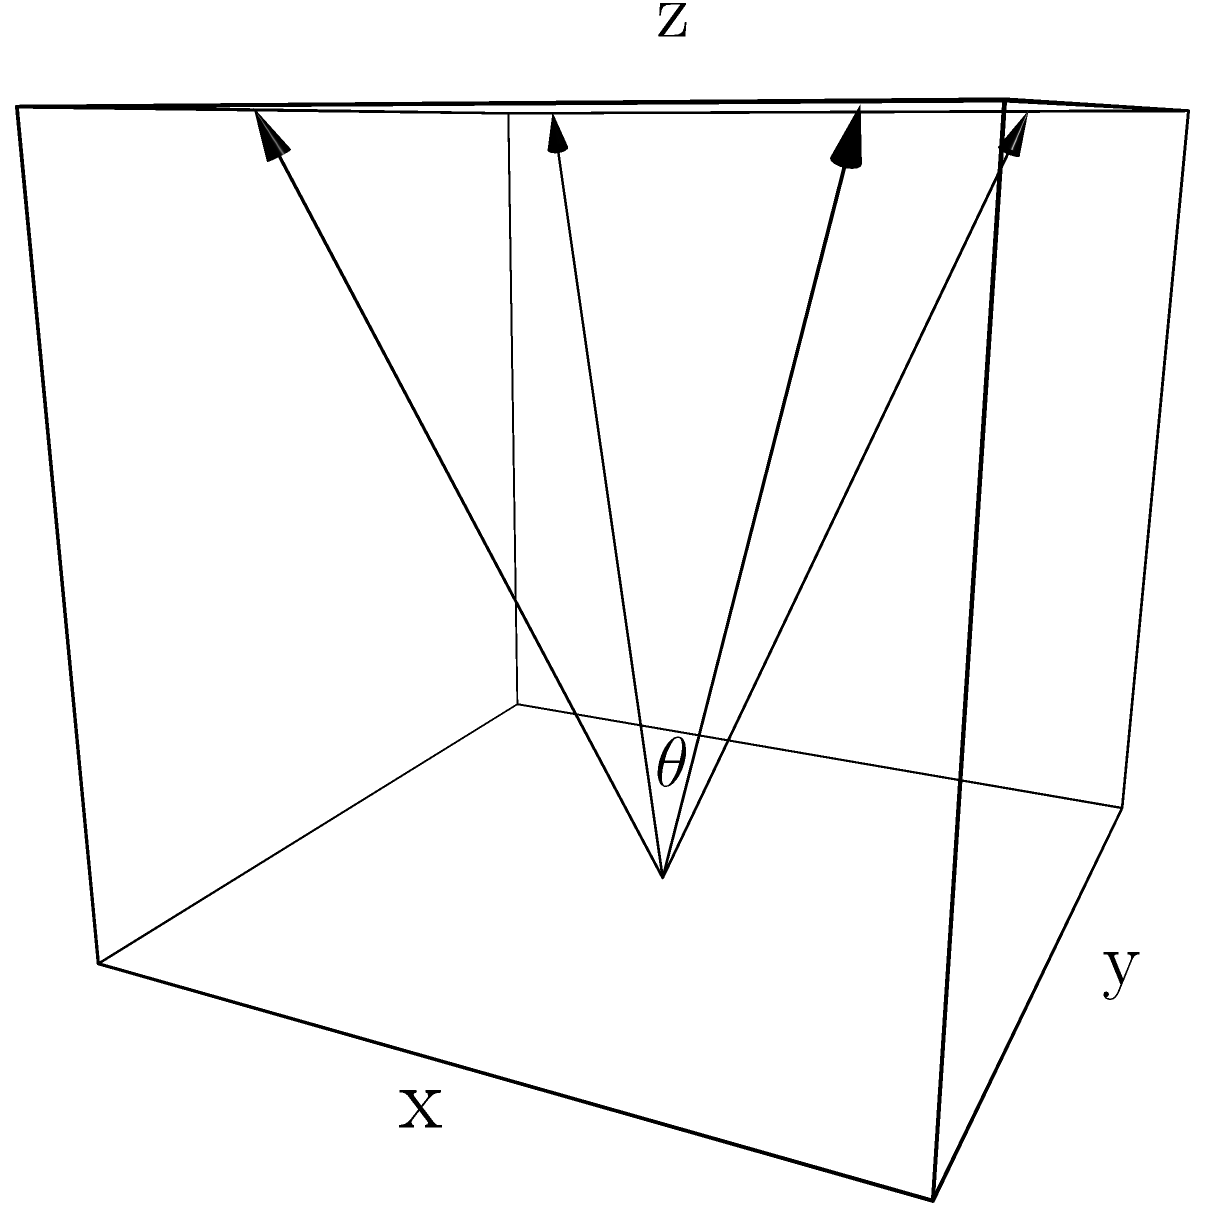In a 3D game environment, you want to optimize the field of view (FOV) to maximize the visible area while maintaining performance. Given that the FOV is represented by an angle $\theta$ and the visible volume $V$ is proportional to $\tan^3(\frac{\theta}{2})$, but the rendering cost $C$ increases linearly with $\theta$, find the optimal angle $\theta$ that maximizes the efficiency $E = \frac{V}{C} = \frac{k\tan^3(\frac{\theta}{2})}{\theta}$, where $k$ is a constant and $0 < \theta < \pi$. To find the optimal angle $\theta$, we need to maximize the efficiency function $E = \frac{k\tan^3(\frac{\theta}{2})}{\theta}$. We can do this by finding where the derivative of $E$ with respect to $\theta$ equals zero.

Step 1: Simplify the expression by removing the constant $k$ (it won't affect the location of the maximum).
$E = \frac{\tan^3(\frac{\theta}{2})}{\theta}$

Step 2: Take the derivative of $E$ with respect to $\theta$ using the quotient rule.
$\frac{dE}{d\theta} = \frac{\theta \cdot 3\tan^2(\frac{\theta}{2}) \cdot \frac{1}{2}\sec^2(\frac{\theta}{2}) - \tan^3(\frac{\theta}{2}) \cdot 1}{\theta^2}$

Step 3: Set the derivative equal to zero and simplify.
$\frac{3\theta\tan^2(\frac{\theta}{2})\sec^2(\frac{\theta}{2})}{2\theta} = \frac{\tan^3(\frac{\theta}{2})}{\theta}$

$\frac{3}{2}\tan(\frac{\theta}{2})\sec^2(\frac{\theta}{2}) = \tan^2(\frac{\theta}{2})$

Step 4: Use the identity $\sec^2(x) = 1 + \tan^2(x)$ to simplify further.
$\frac{3}{2}\tan(\frac{\theta}{2})(1 + \tan^2(\frac{\theta}{2})) = \tan^2(\frac{\theta}{2})$

$\frac{3}{2}\tan(\frac{\theta}{2}) + \frac{3}{2}\tan^3(\frac{\theta}{2}) = \tan^2(\frac{\theta}{2})$

Step 5: Let $u = \tan(\frac{\theta}{2})$ to simplify the equation.
$\frac{3}{2}u + \frac{3}{2}u^3 = u^2$

$3u + 3u^3 = 2u^2$

$3u^3 - 2u^2 + 3u = 0$

$3u(u^2 - \frac{2}{3}u + 1) = 0$

Step 6: Solve the equation. The solution $u = 0$ is not valid for our problem, so we solve:
$u^2 - \frac{2}{3}u + 1 = 0$

Using the quadratic formula, we get:
$u = \frac{\frac{2}{3} \pm \sqrt{(\frac{2}{3})^2 - 4}}{2} = \frac{1}{3} \pm \frac{\sqrt{5}}{3}$

We take the positive solution as $\tan(\frac{\theta}{2})$ is positive in our domain.

Step 7: Solve for $\theta$.
$\tan(\frac{\theta}{2}) = \frac{1}{3} + \frac{\sqrt{5}}{3}$

$\theta = 2\arctan(\frac{1}{3} + \frac{\sqrt{5}}{3})$
Answer: $\theta = 2\arctan(\frac{1}{3} + \frac{\sqrt{5}}{3}) \approx 2.0944$ radians or $120°$ 